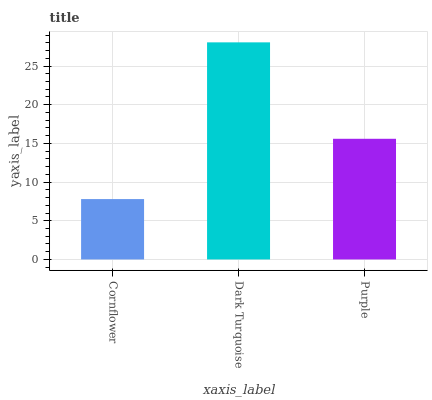Is Purple the minimum?
Answer yes or no. No. Is Purple the maximum?
Answer yes or no. No. Is Dark Turquoise greater than Purple?
Answer yes or no. Yes. Is Purple less than Dark Turquoise?
Answer yes or no. Yes. Is Purple greater than Dark Turquoise?
Answer yes or no. No. Is Dark Turquoise less than Purple?
Answer yes or no. No. Is Purple the high median?
Answer yes or no. Yes. Is Purple the low median?
Answer yes or no. Yes. Is Dark Turquoise the high median?
Answer yes or no. No. Is Cornflower the low median?
Answer yes or no. No. 